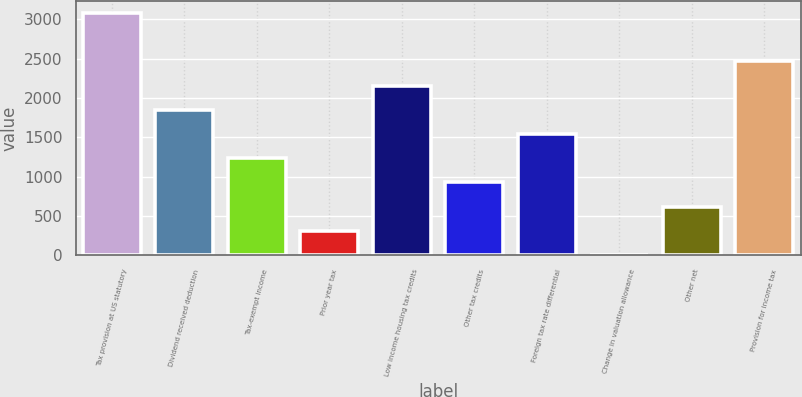Convert chart to OTSL. <chart><loc_0><loc_0><loc_500><loc_500><bar_chart><fcel>Tax provision at US statutory<fcel>Dividend received deduction<fcel>Tax-exempt income<fcel>Prior year tax<fcel>Low income housing tax credits<fcel>Other tax credits<fcel>Foreign tax rate differential<fcel>Change in valuation allowance<fcel>Other net<fcel>Provision for income tax<nl><fcel>3081<fcel>1849.8<fcel>1234.2<fcel>310.8<fcel>2157.6<fcel>926.4<fcel>1542<fcel>3<fcel>618.6<fcel>2465.4<nl></chart> 